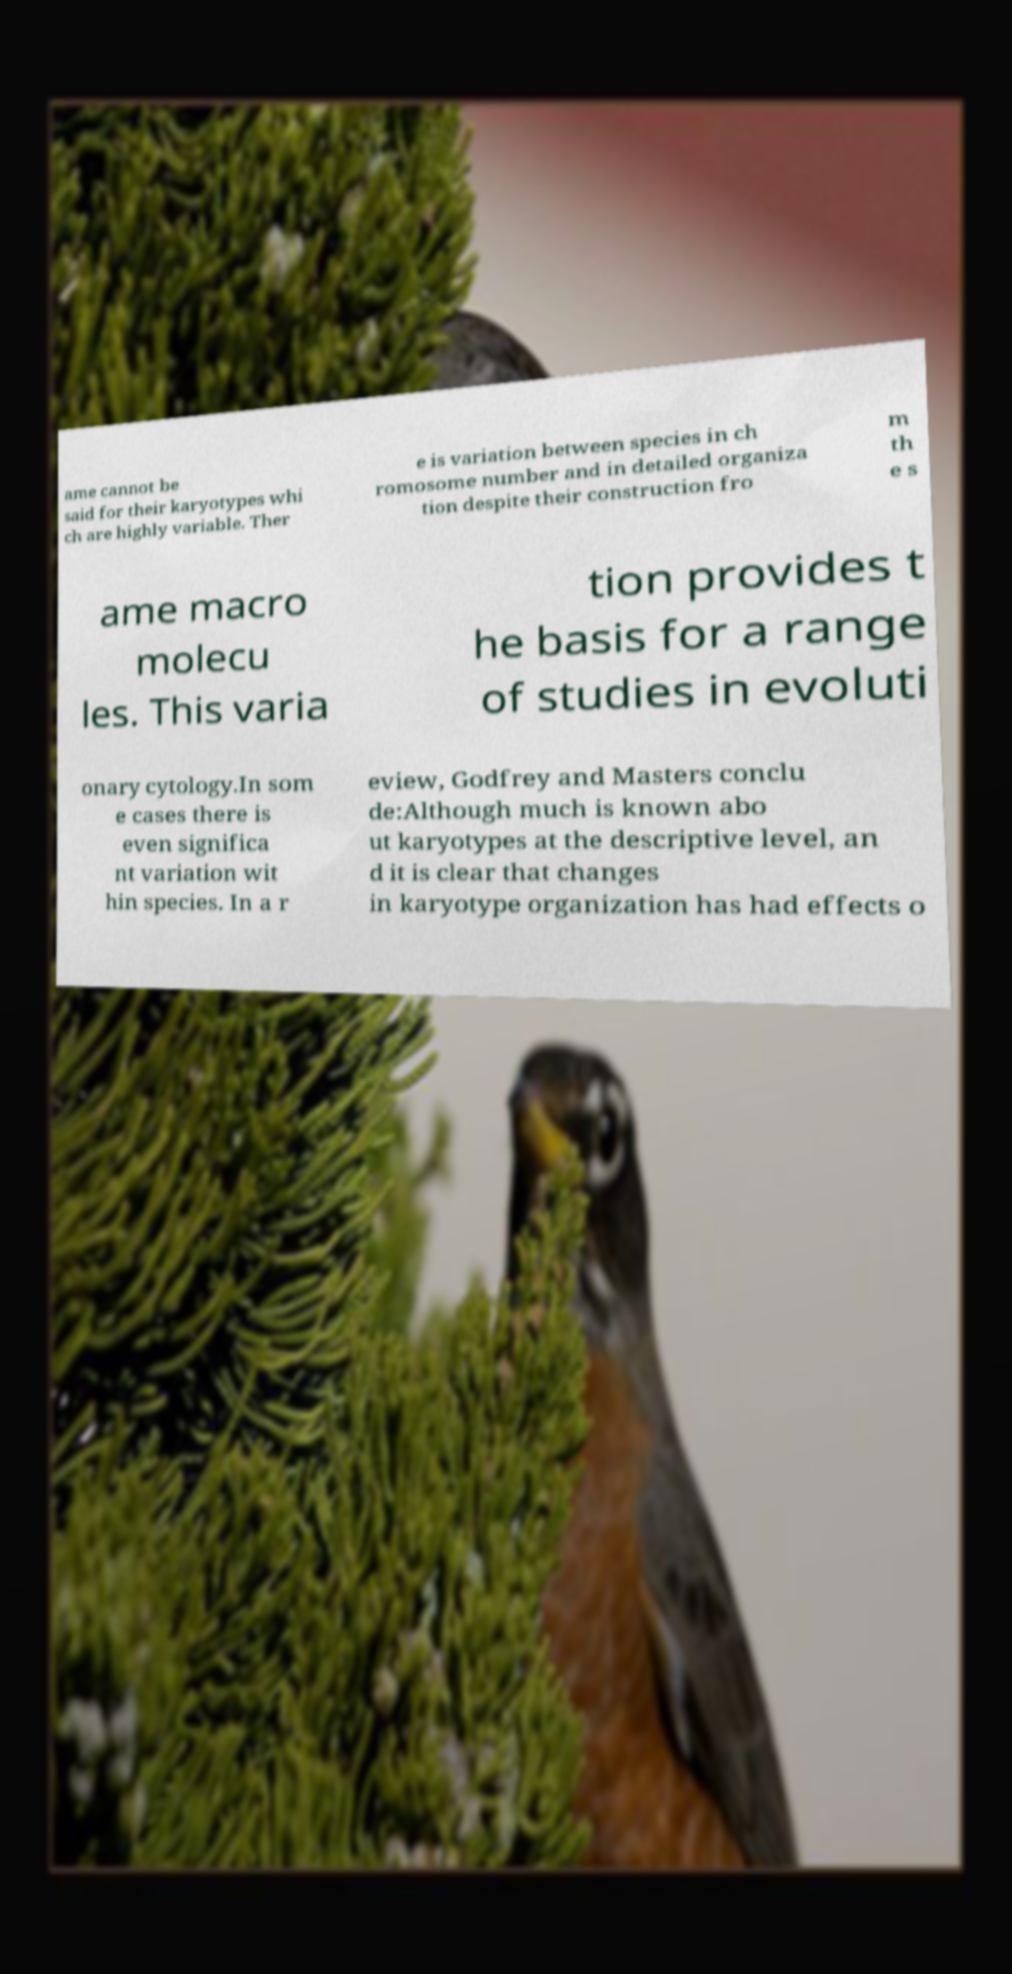Can you read and provide the text displayed in the image?This photo seems to have some interesting text. Can you extract and type it out for me? ame cannot be said for their karyotypes whi ch are highly variable. Ther e is variation between species in ch romosome number and in detailed organiza tion despite their construction fro m th e s ame macro molecu les. This varia tion provides t he basis for a range of studies in evoluti onary cytology.In som e cases there is even significa nt variation wit hin species. In a r eview, Godfrey and Masters conclu de:Although much is known abo ut karyotypes at the descriptive level, an d it is clear that changes in karyotype organization has had effects o 